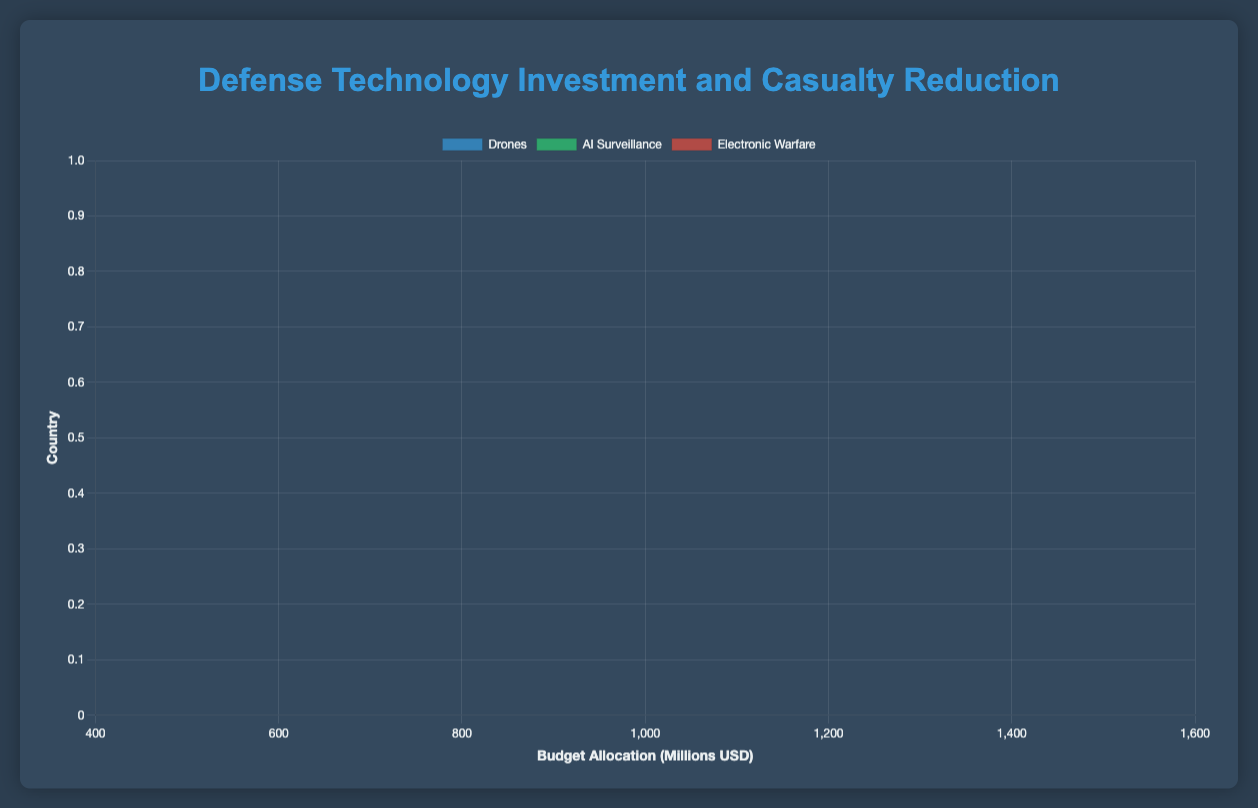Which country has the highest budget allocation for drones? The bar representing the USA’s budget allocation for drones is the longest, indicating that the USA spends the most on drones.
Answer: USA What is the average casualty reduction percentage for AI Surveillance across all countries? The percentages are 20 (USA), 18 (UK), 21 (Germany), 22 (Japan), and 19 (Australia). Summing these gives 100, and dividing by 5 gives an average of 20%.
Answer: 20% Compare the budget allocation between Japan and the UK for electronic warfare. Japan’s budget allocation (550 million USD) is compared to the UK's (500 million USD). Japan spends 50 million USD more than the UK.
Answer: Japan spends 50 million more What is the total budget allocation for drones by all countries? Summing the budget allocations for drones: 1500 (USA) + 800 (UK) + 700 (Germany) + 900 (Japan) + 600 (Australia) = 4500 million USD.
Answer: 4500 million USD Which technology investment in Australia provides the highest casualty reduction percentage? The bars representing Australia show that AI Surveillance has the highest casualty reduction percentage with 19%.
Answer: AI Surveillance What is the difference in casualty reduction percentage between drones and AI Surveillance in Germany? The casualty reduction percentages for Germany are 14% for drones and 21% for AI Surveillance. The difference is 21 - 14 = 7%.
Answer: 7% How does the USA's budget allocation for electronic warfare compare to its AI Surveillance allocation? The USA allocates 1000 million USD for electronic warfare and 1200 million USD for AI Surveillance, so it allocates 200 million USD less for electronic warfare.
Answer: 200 million USD less Which country has the lowest casualty reduction percentage for electronic warfare? The bar representing the UK shows the lowest casualty reduction percentage for electronic warfare at 8%.
Answer: UK Rank the countries by their budget allocation for AI Surveillance from highest to lowest. The budget allocations for AI surveillance are 1200 (USA), 750 (Japan), 650 (Germany), 600 (UK), and 500 (Australia). The ranking from highest to lowest is: USA, Japan, Germany, UK, Australia.
Answer: USA, Japan, Germany, UK, Australia 